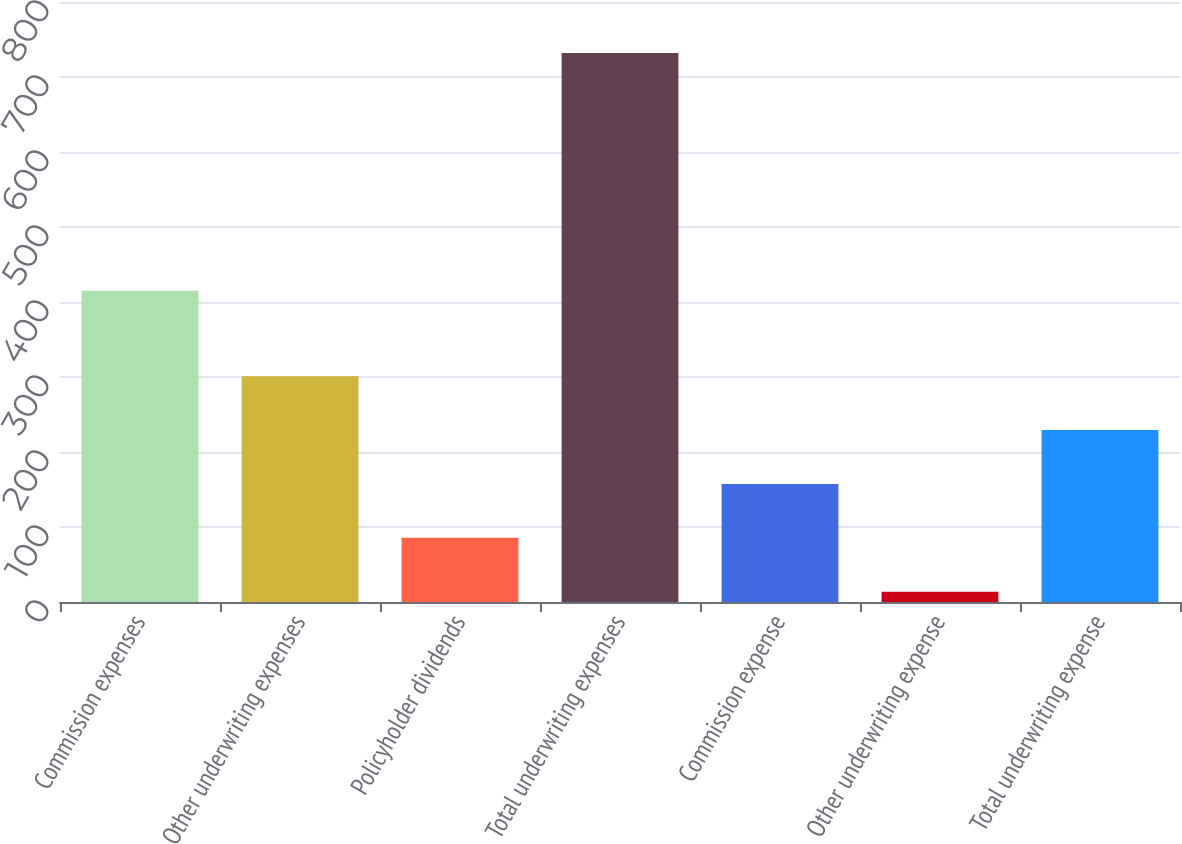Convert chart to OTSL. <chart><loc_0><loc_0><loc_500><loc_500><bar_chart><fcel>Commission expenses<fcel>Other underwriting expenses<fcel>Policyholder dividends<fcel>Total underwriting expenses<fcel>Commission expense<fcel>Other underwriting expense<fcel>Total underwriting expense<nl><fcel>415<fcel>301.08<fcel>85.62<fcel>732<fcel>157.44<fcel>13.8<fcel>229.26<nl></chart> 